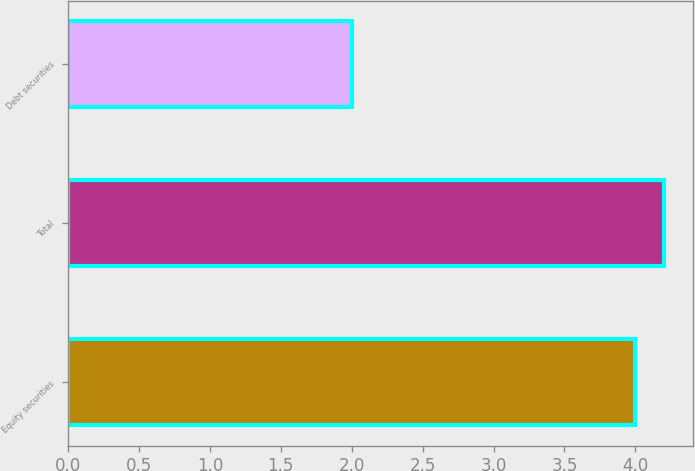<chart> <loc_0><loc_0><loc_500><loc_500><bar_chart><fcel>Equity securities<fcel>Total<fcel>Debt securities<nl><fcel>4<fcel>4.2<fcel>2<nl></chart> 